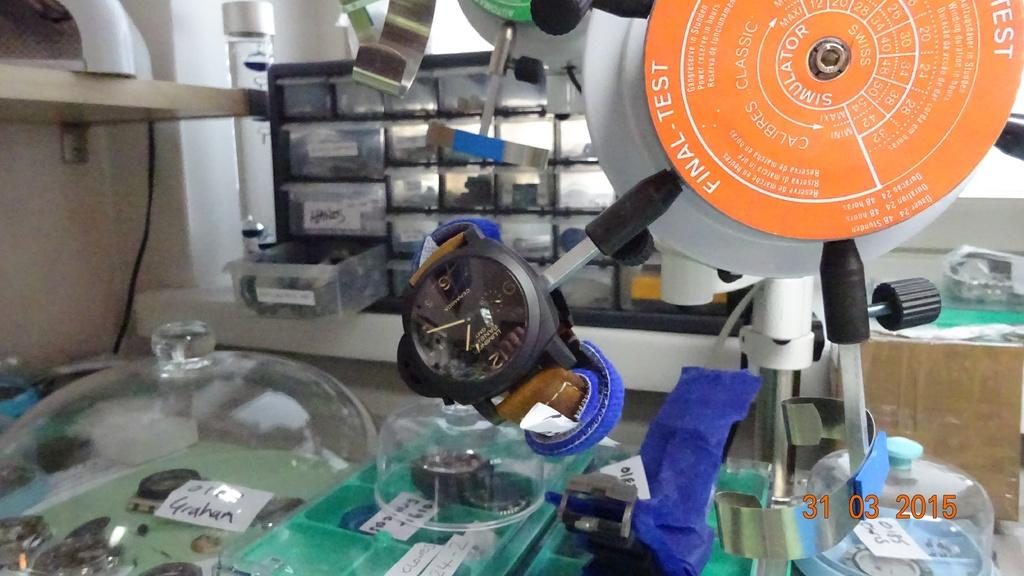What types of objects can be seen in the image? There are electrical objects and plastic boxes on shelves in the image. Can you describe the electrical objects in the image? Unfortunately, the specific electrical objects cannot be identified from the provided facts. How are the plastic boxes arranged in the image? The plastic boxes are arranged on shelves in the image. What arithmetic problem is being solved on the plastic boxes in the image? There is no arithmetic problem visible on the plastic boxes in the image. What type of smell can be detected from the electrical objects in the image? The provided facts do not mention any smells associated with the electrical objects in the image. 